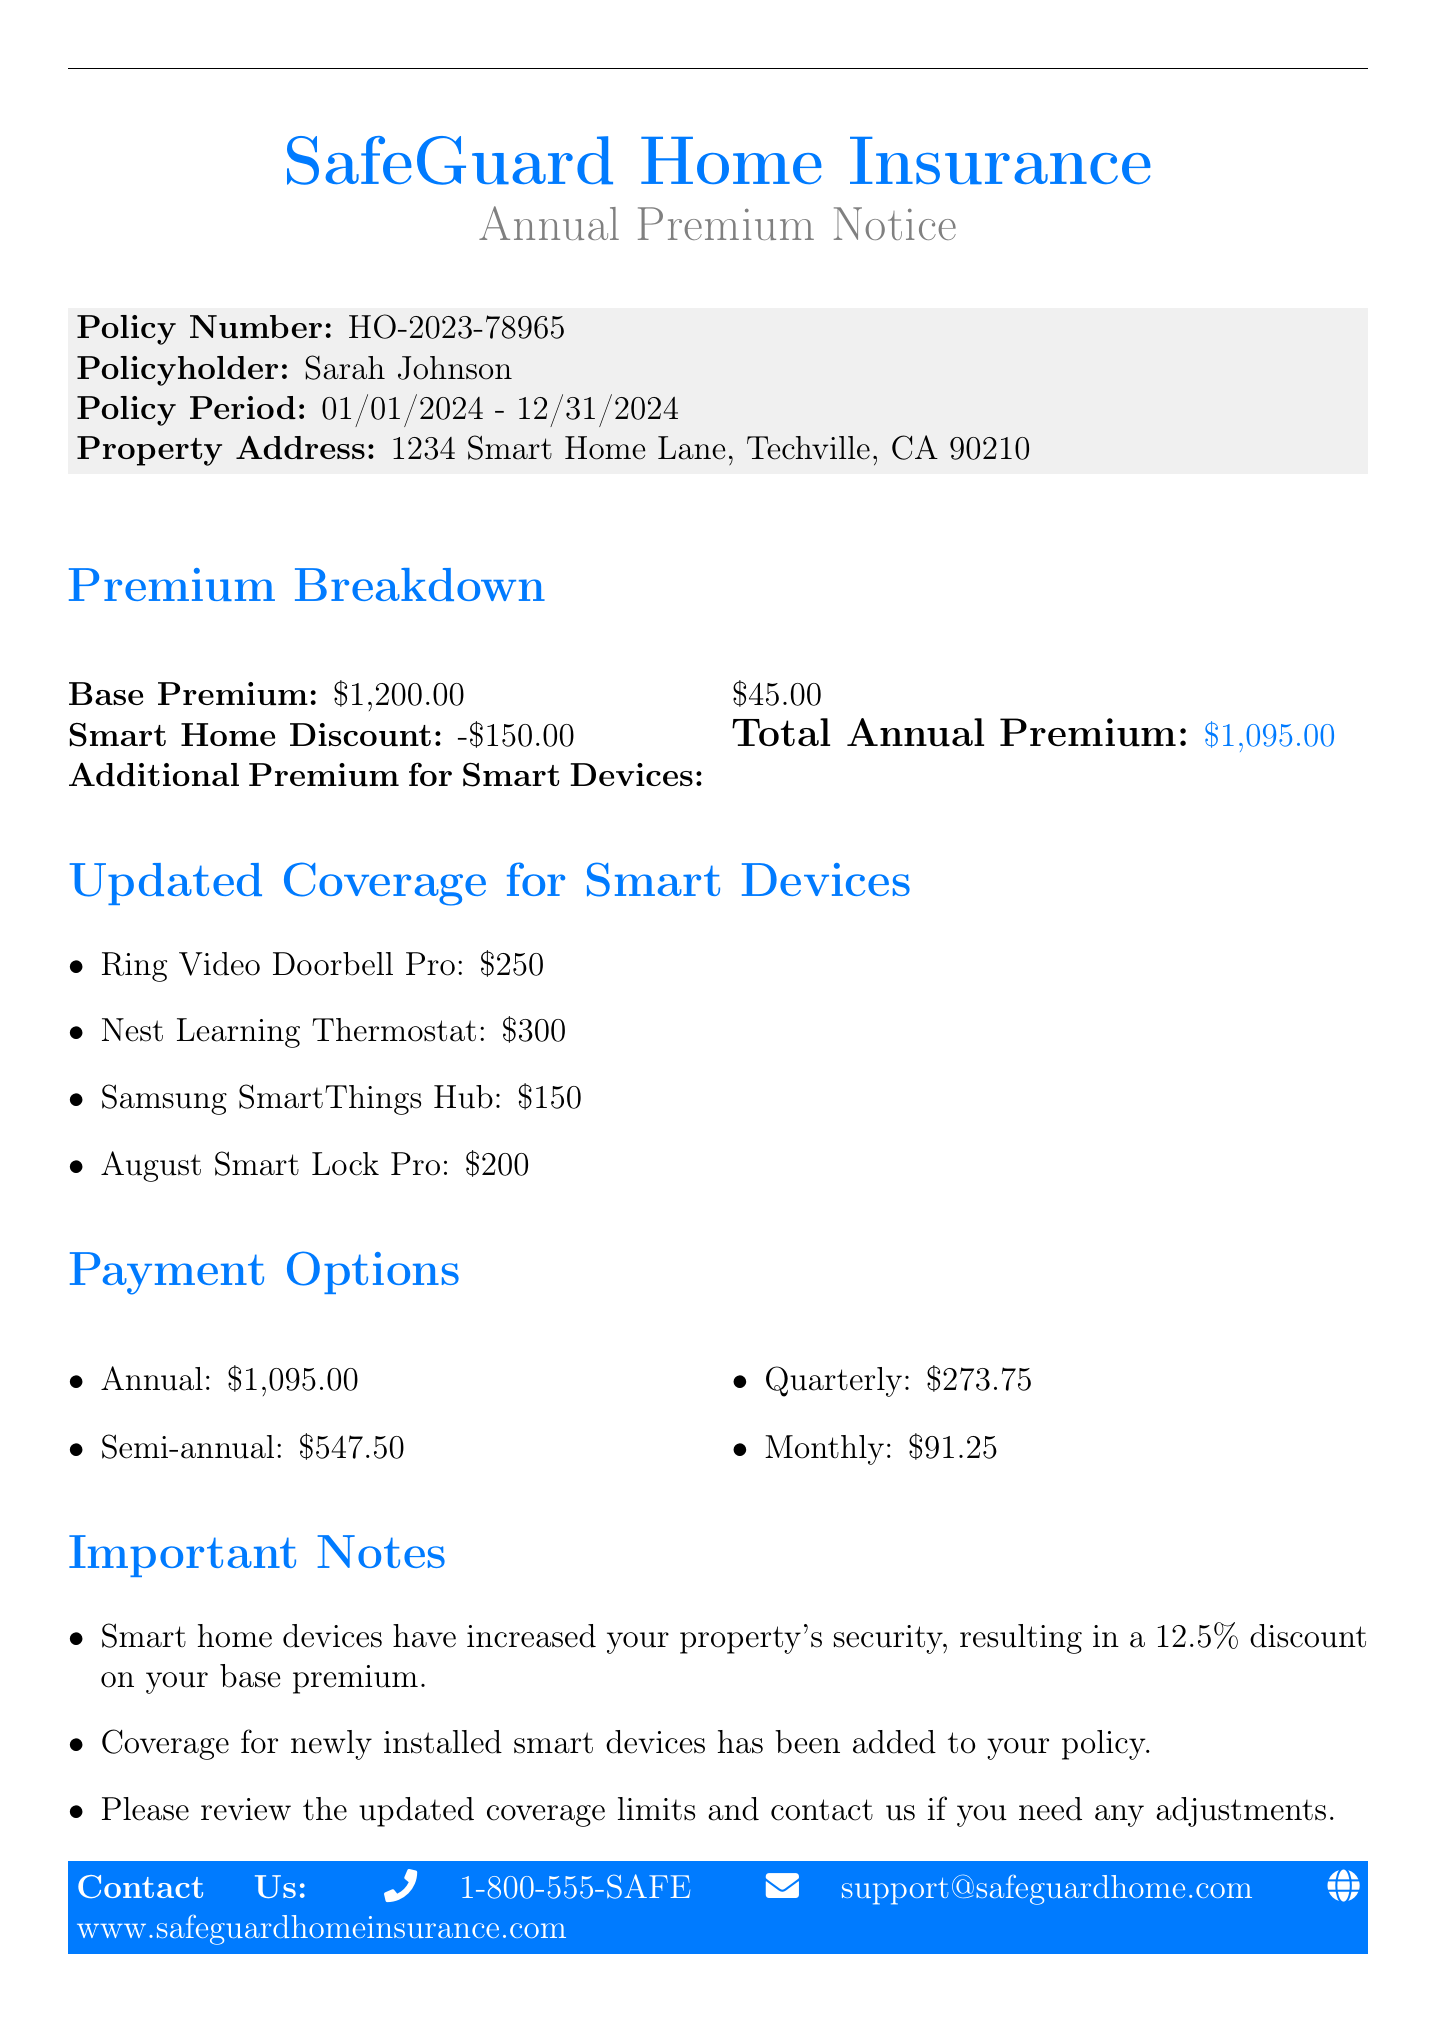What is the policy number? The policy number is mentioned in the document as HO-2023-78965.
Answer: HO-2023-78965 Who is the policyholder? The policyholder's name is listed in the document as Sarah Johnson.
Answer: Sarah Johnson What is the total annual premium? The total annual premium is the final amount shown in the premium breakdown, which is $1,095.00.
Answer: $1,095.00 What discount was applied for smart home devices? A 12.5% discount was noted for the base premium due to installed smart home devices.
Answer: 12.5% How much is the coverage for the Nest Learning Thermostat? The coverage amount for the Nest Learning Thermostat is specified in the updated coverage section as $300.
Answer: $300 What are the payment options for the annual premium? The document provides several payment options, but the full details can be summarized as annual, semi-annual, quarterly, and monthly.
Answer: Annual, semi-annual, quarterly, monthly What is the value of the Ring Video Doorbell Pro coverage? The Ring Video Doorbell Pro coverage amount is listed in the document as $250.
Answer: $250 When does the policy period start? The policy period is stated as starting on January 1, 2024.
Answer: 01/01/2024 What are the contact options listed in the document? The contact options include a phone number, an email, and a website as provided in the footer.
Answer: 1-800-555-SAFE, support@safeguardhome.com, www.safeguardhomeinsurance.com 